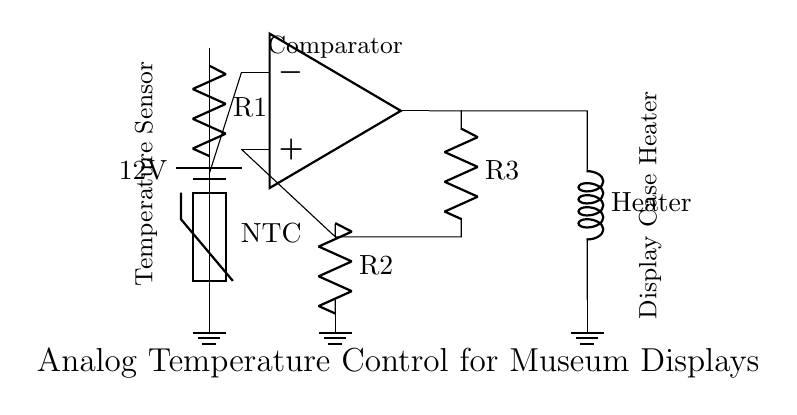What is the power supply voltage? The circuit is powered by a battery, and the voltage of the battery is clearly labeled as twelve volts.
Answer: twelve volts What type of thermistor is used in this circuit? The thermistor is labeled as an NTC (Negative Temperature Coefficient), indicating that its resistance decreases with an increase in temperature.
Answer: NTC How many resistors are in the circuit? By counting the components labeled as resistors, there are three resistors denoted as R1, R2, and R3 in the circuit diagram.
Answer: three What does the op-amp function as in this circuit? The op-amp is connected to serve as a comparator, which compares the voltage from the thermistor against a reference voltage to control the output.
Answer: comparator What component is responsible for heating the display case? The output from the circuit is connected to a component labeled as the Heater, which indicates it is responsible for maintaining the temperature of the display case.
Answer: Heater How does the feedback loop from the op-amp work? The output from the op-amp is fed back into the circuit through resistor R3, creating a feedback loop that adjusts the input based on the temperature sensor's reading, thus maintaining the desired temperature setting.
Answer: feedback loop What occurs when the temperature rises above the set point? If the temperature exceeds the set point, the comparator (op-amp) will trigger a change in the output, potentially switching off the Heater to prevent overheating.
Answer: switch off Heater 